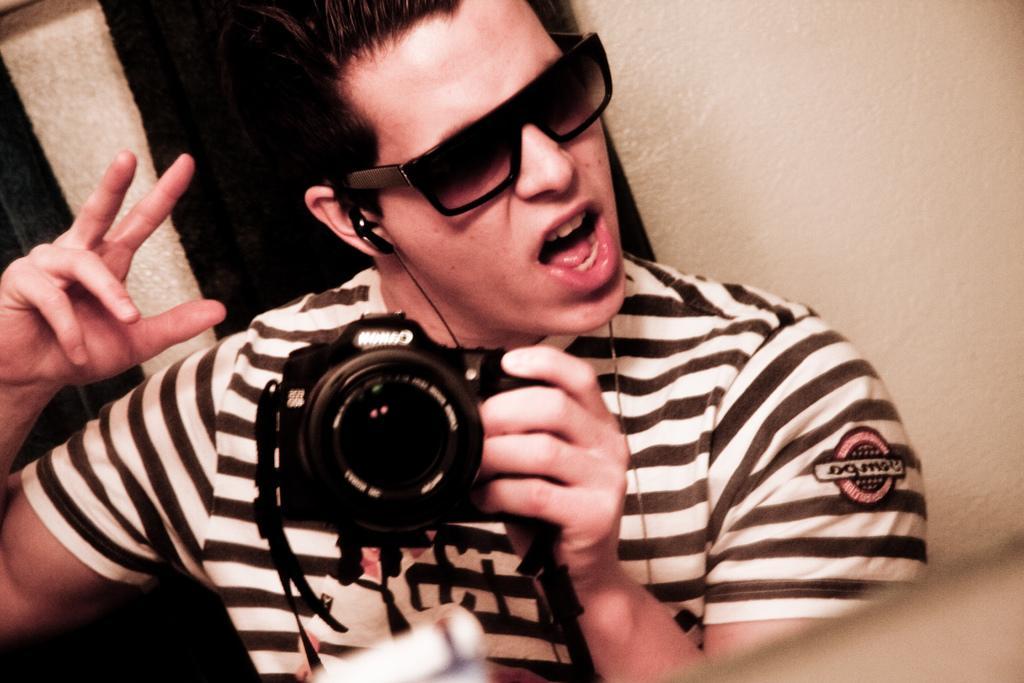Could you give a brief overview of what you see in this image? This man wore goggles and holding camera. 